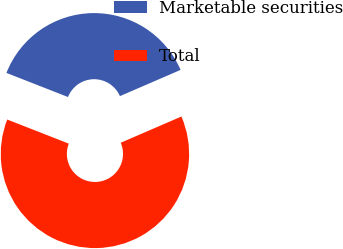Convert chart to OTSL. <chart><loc_0><loc_0><loc_500><loc_500><pie_chart><fcel>Marketable securities<fcel>Total<nl><fcel>37.56%<fcel>62.44%<nl></chart> 